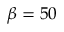Convert formula to latex. <formula><loc_0><loc_0><loc_500><loc_500>\beta = 5 0</formula> 